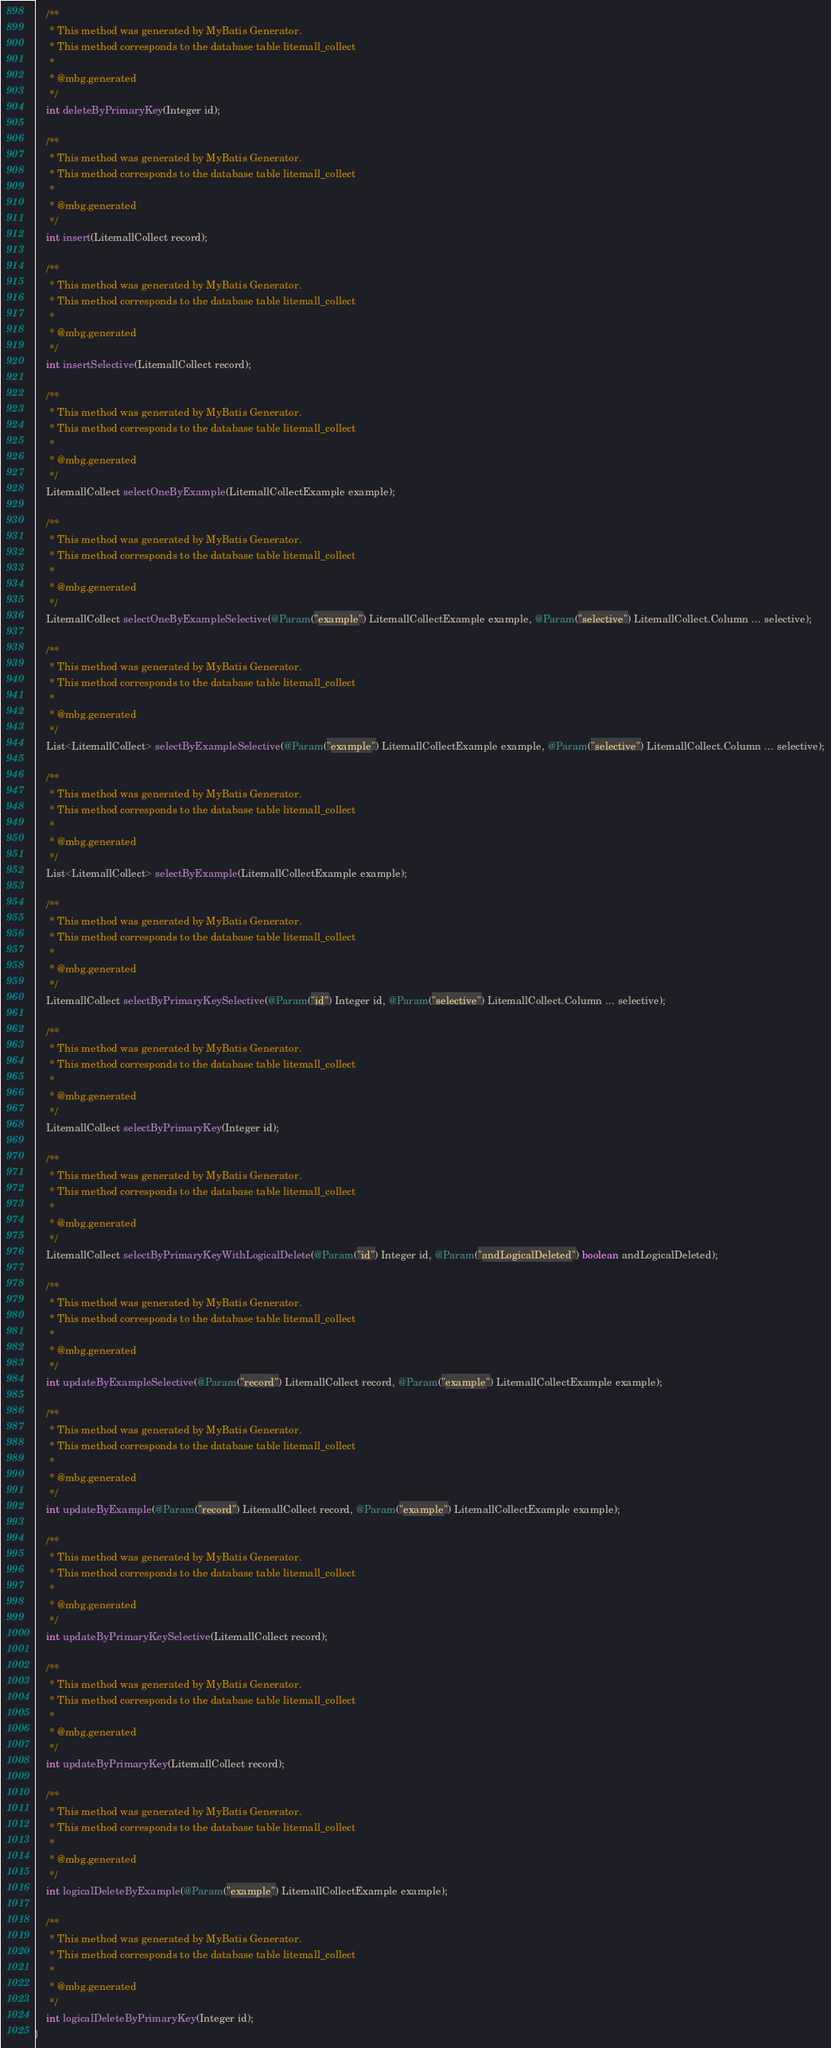Convert code to text. <code><loc_0><loc_0><loc_500><loc_500><_Java_>    /**
     * This method was generated by MyBatis Generator.
     * This method corresponds to the database table litemall_collect
     *
     * @mbg.generated
     */
    int deleteByPrimaryKey(Integer id);

    /**
     * This method was generated by MyBatis Generator.
     * This method corresponds to the database table litemall_collect
     *
     * @mbg.generated
     */
    int insert(LitemallCollect record);

    /**
     * This method was generated by MyBatis Generator.
     * This method corresponds to the database table litemall_collect
     *
     * @mbg.generated
     */
    int insertSelective(LitemallCollect record);

    /**
     * This method was generated by MyBatis Generator.
     * This method corresponds to the database table litemall_collect
     *
     * @mbg.generated
     */
    LitemallCollect selectOneByExample(LitemallCollectExample example);

    /**
     * This method was generated by MyBatis Generator.
     * This method corresponds to the database table litemall_collect
     *
     * @mbg.generated
     */
    LitemallCollect selectOneByExampleSelective(@Param("example") LitemallCollectExample example, @Param("selective") LitemallCollect.Column ... selective);

    /**
     * This method was generated by MyBatis Generator.
     * This method corresponds to the database table litemall_collect
     *
     * @mbg.generated
     */
    List<LitemallCollect> selectByExampleSelective(@Param("example") LitemallCollectExample example, @Param("selective") LitemallCollect.Column ... selective);

    /**
     * This method was generated by MyBatis Generator.
     * This method corresponds to the database table litemall_collect
     *
     * @mbg.generated
     */
    List<LitemallCollect> selectByExample(LitemallCollectExample example);

    /**
     * This method was generated by MyBatis Generator.
     * This method corresponds to the database table litemall_collect
     *
     * @mbg.generated
     */
    LitemallCollect selectByPrimaryKeySelective(@Param("id") Integer id, @Param("selective") LitemallCollect.Column ... selective);

    /**
     * This method was generated by MyBatis Generator.
     * This method corresponds to the database table litemall_collect
     *
     * @mbg.generated
     */
    LitemallCollect selectByPrimaryKey(Integer id);

    /**
     * This method was generated by MyBatis Generator.
     * This method corresponds to the database table litemall_collect
     *
     * @mbg.generated
     */
    LitemallCollect selectByPrimaryKeyWithLogicalDelete(@Param("id") Integer id, @Param("andLogicalDeleted") boolean andLogicalDeleted);

    /**
     * This method was generated by MyBatis Generator.
     * This method corresponds to the database table litemall_collect
     *
     * @mbg.generated
     */
    int updateByExampleSelective(@Param("record") LitemallCollect record, @Param("example") LitemallCollectExample example);

    /**
     * This method was generated by MyBatis Generator.
     * This method corresponds to the database table litemall_collect
     *
     * @mbg.generated
     */
    int updateByExample(@Param("record") LitemallCollect record, @Param("example") LitemallCollectExample example);

    /**
     * This method was generated by MyBatis Generator.
     * This method corresponds to the database table litemall_collect
     *
     * @mbg.generated
     */
    int updateByPrimaryKeySelective(LitemallCollect record);

    /**
     * This method was generated by MyBatis Generator.
     * This method corresponds to the database table litemall_collect
     *
     * @mbg.generated
     */
    int updateByPrimaryKey(LitemallCollect record);

    /**
     * This method was generated by MyBatis Generator.
     * This method corresponds to the database table litemall_collect
     *
     * @mbg.generated
     */
    int logicalDeleteByExample(@Param("example") LitemallCollectExample example);

    /**
     * This method was generated by MyBatis Generator.
     * This method corresponds to the database table litemall_collect
     *
     * @mbg.generated
     */
    int logicalDeleteByPrimaryKey(Integer id);
}</code> 